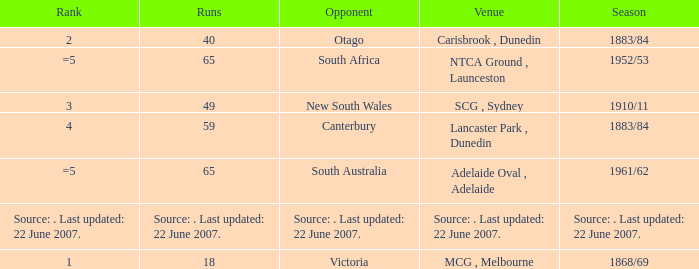Which Runs has a Rank of =5 and an Opponent of south australia? 65.0. 